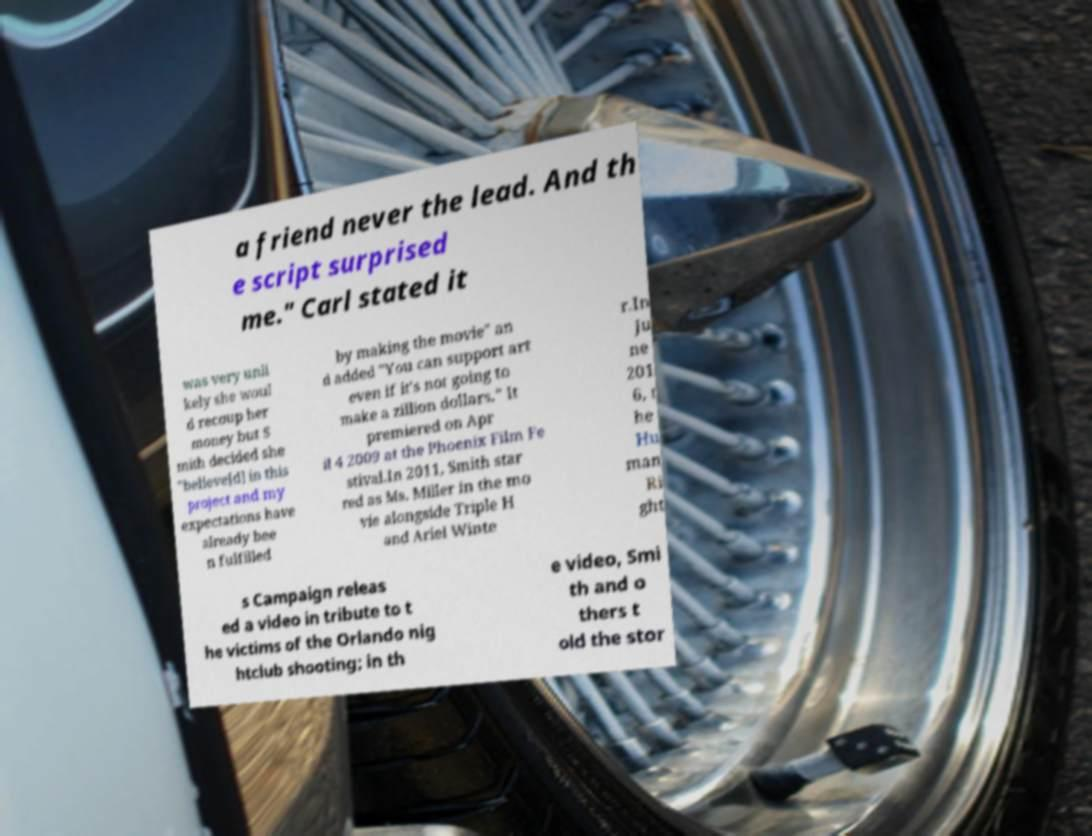Can you read and provide the text displayed in the image?This photo seems to have some interesting text. Can you extract and type it out for me? a friend never the lead. And th e script surprised me." Carl stated it was very unli kely she woul d recoup her money but S mith decided she "believe[d] in this project and my expectations have already bee n fulfilled by making the movie" an d added "You can support art even if it's not going to make a zillion dollars." It premiered on Apr il 4 2009 at the Phoenix Film Fe stival.In 2011, Smith star red as Ms. Miller in the mo vie alongside Triple H and Ariel Winte r.In Ju ne 201 6, t he Hu man Ri ght s Campaign releas ed a video in tribute to t he victims of the Orlando nig htclub shooting; in th e video, Smi th and o thers t old the stor 